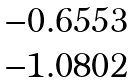Convert formula to latex. <formula><loc_0><loc_0><loc_500><loc_500>\begin{matrix} - 0 . 6 5 5 3 \\ - 1 . 0 8 0 2 \end{matrix}</formula> 